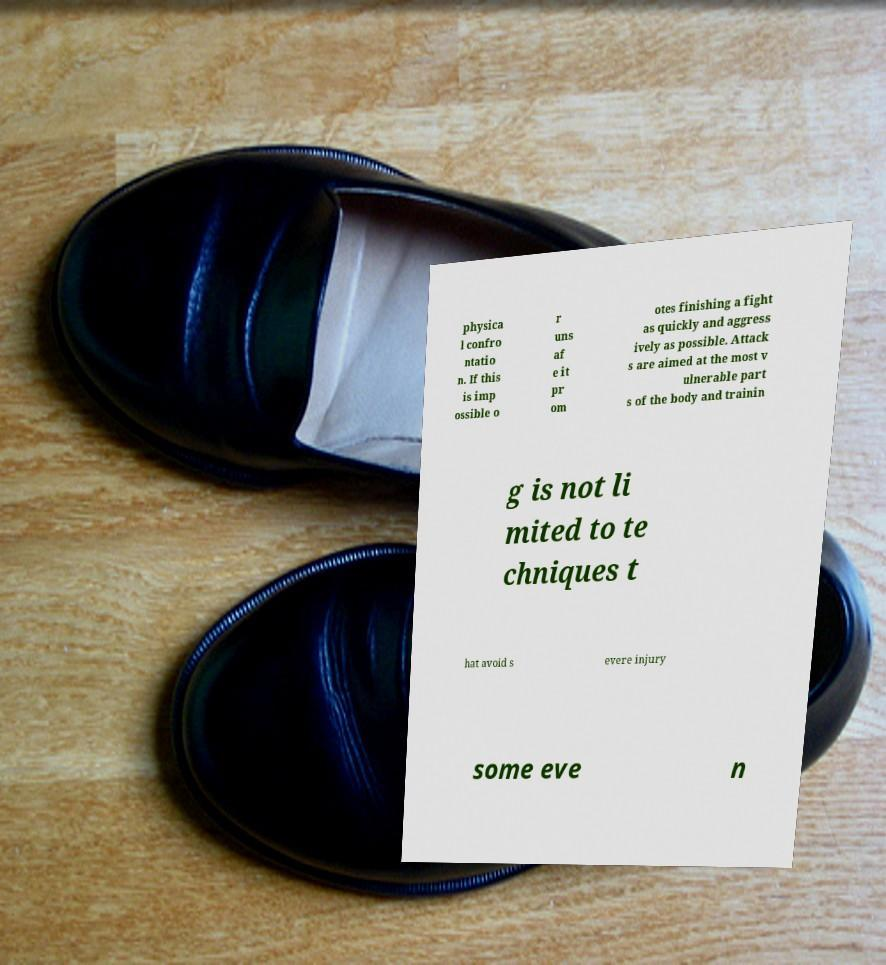Please identify and transcribe the text found in this image. physica l confro ntatio n. If this is imp ossible o r uns af e it pr om otes finishing a fight as quickly and aggress ively as possible. Attack s are aimed at the most v ulnerable part s of the body and trainin g is not li mited to te chniques t hat avoid s evere injury some eve n 